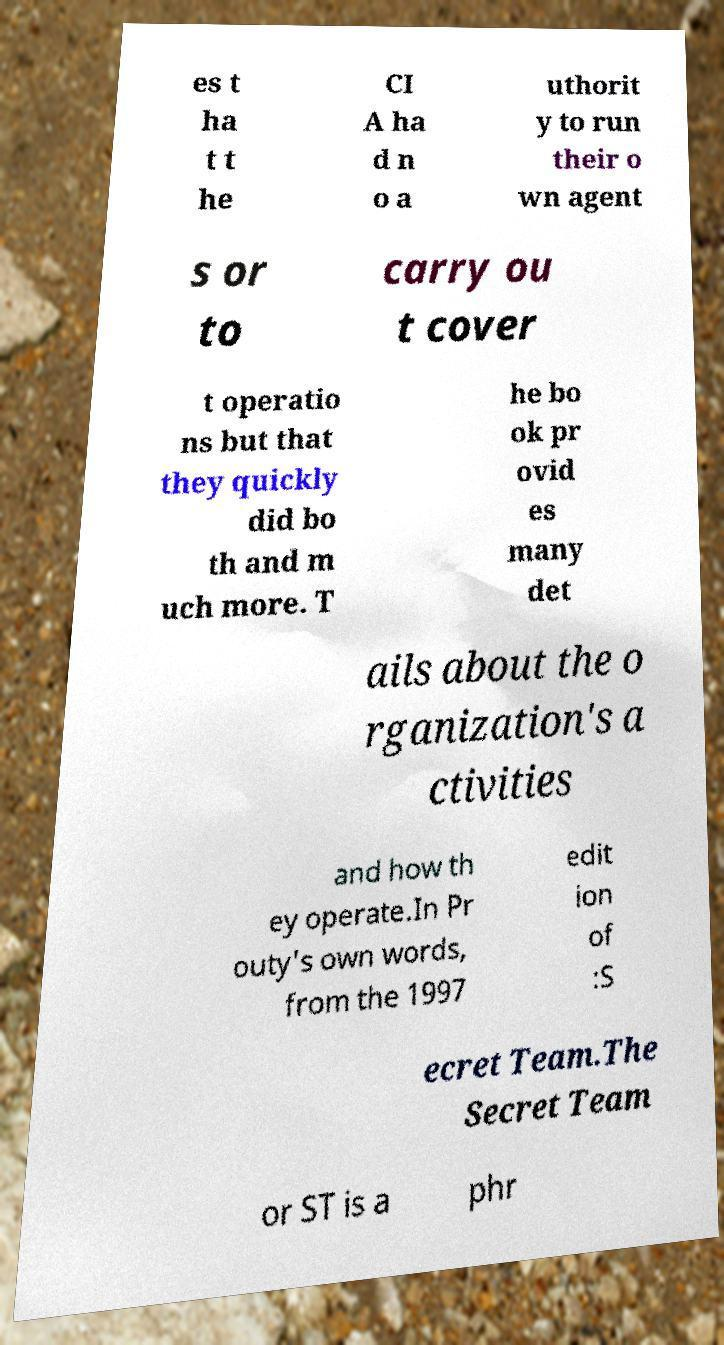Can you read and provide the text displayed in the image?This photo seems to have some interesting text. Can you extract and type it out for me? es t ha t t he CI A ha d n o a uthorit y to run their o wn agent s or to carry ou t cover t operatio ns but that they quickly did bo th and m uch more. T he bo ok pr ovid es many det ails about the o rganization's a ctivities and how th ey operate.In Pr outy's own words, from the 1997 edit ion of :S ecret Team.The Secret Team or ST is a phr 